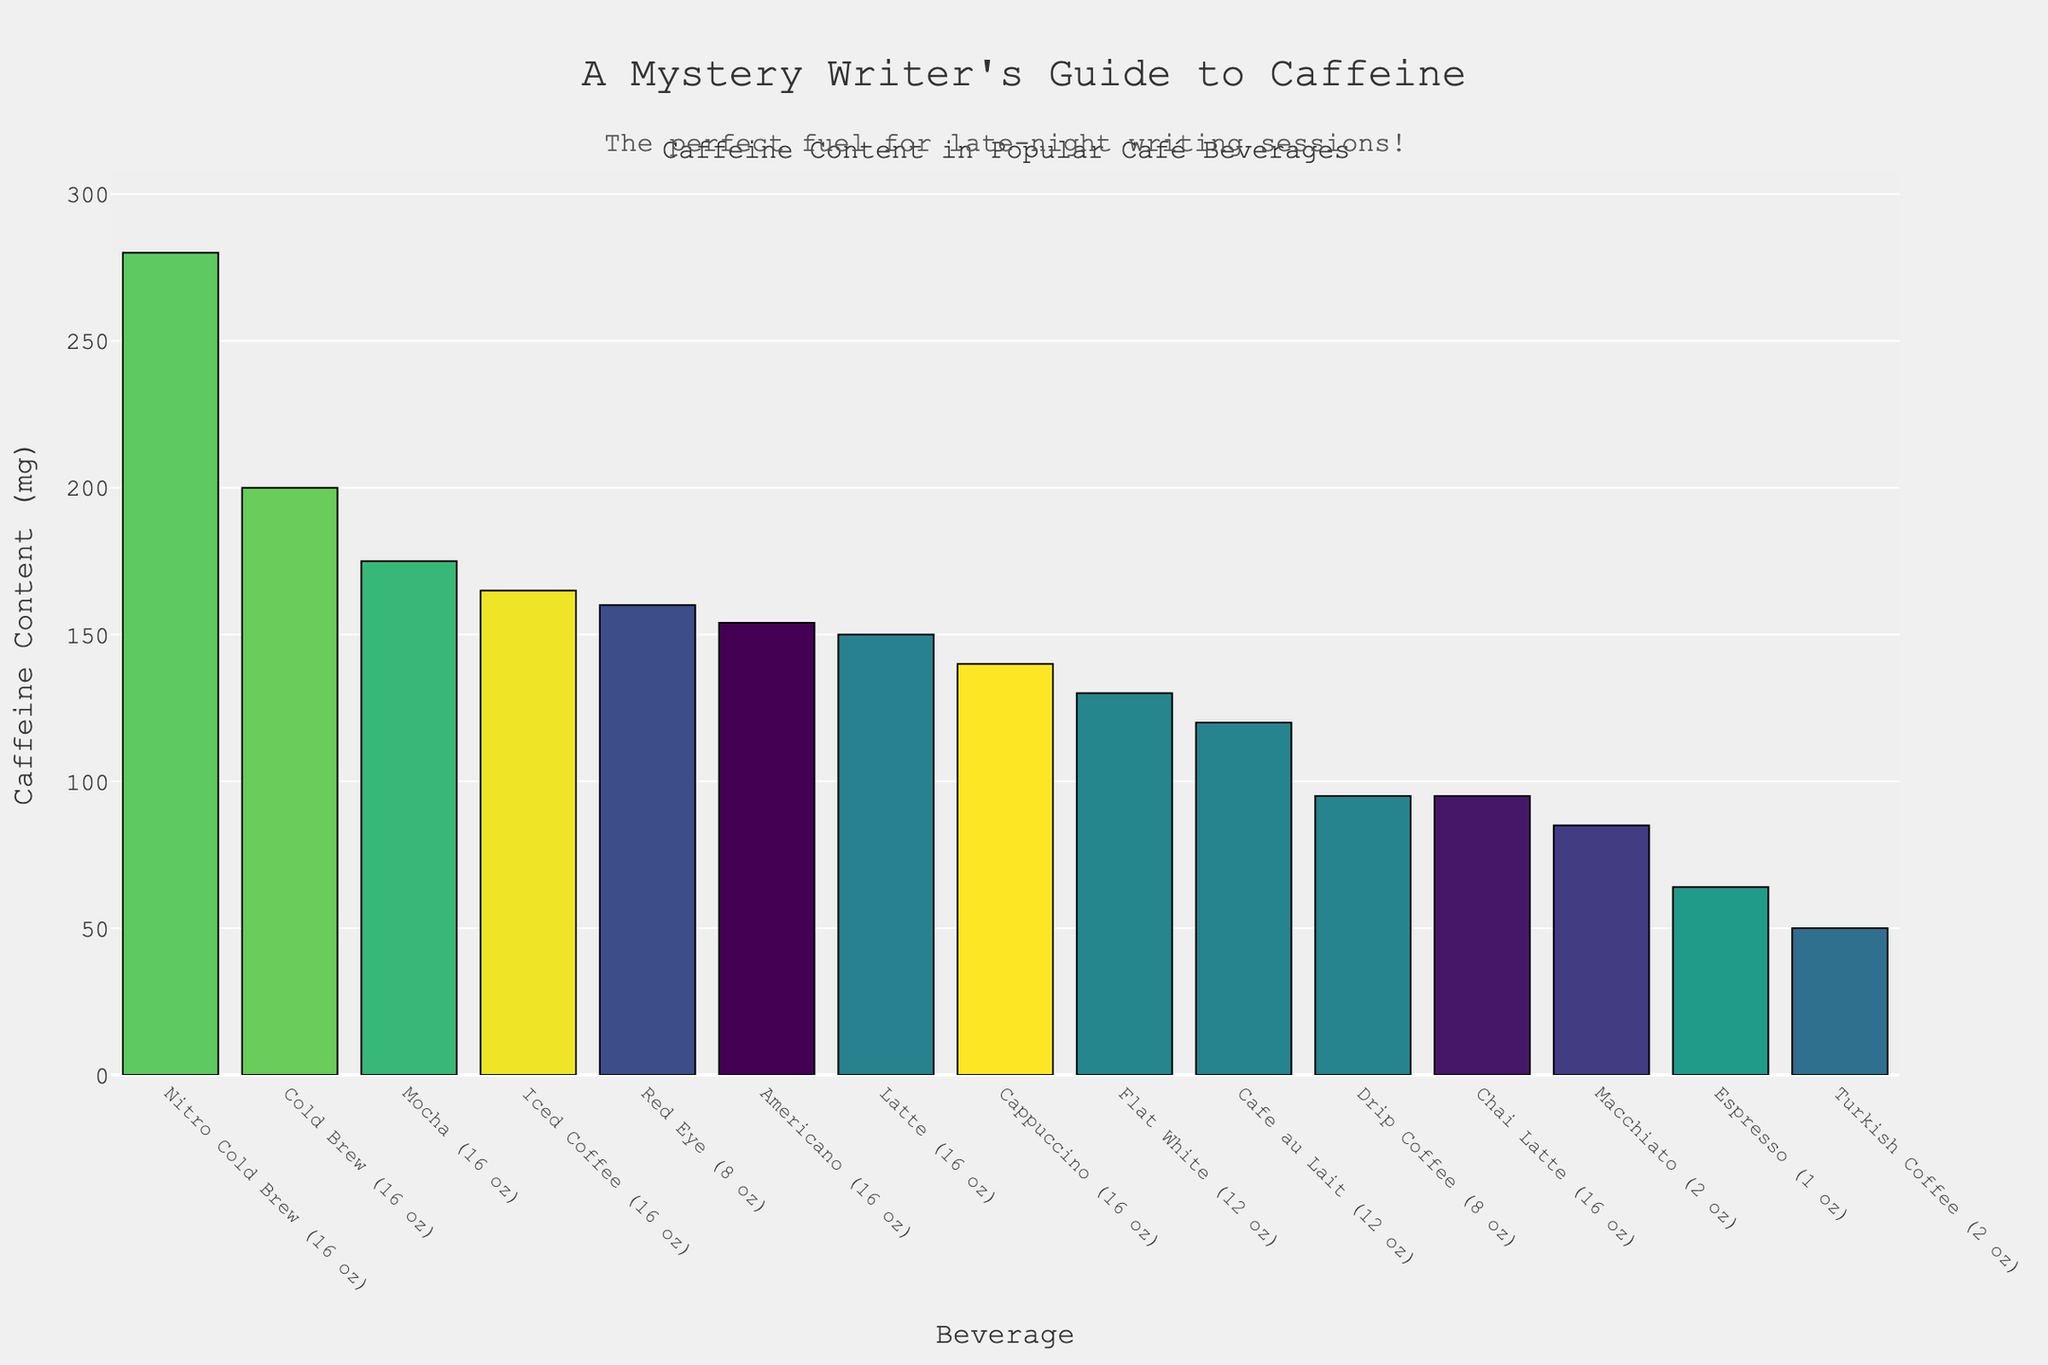What's the beverage with the highest caffeine content? To determine this, look for the tallest bar in the chart. The highest bar represents Nitro Cold Brew with 280 mg of caffeine.
Answer: Nitro Cold Brew Which beverage contains less caffeine: Latte or Cappuccino? Compare the heights of the bars marked for Latte and Cappuccino. The Latte's bar is slightly taller than the Cappuccino's, indicating that Latte has 150 mg of caffeine, while Cappuccino has 140 mg.
Answer: Cappuccino How much more caffeine does Nitro Cold Brew have compared to Espresso? Identify the caffeine amounts for Nitro Cold Brew (280 mg) and Espresso (64 mg) and subtract the smaller value from the larger one: 280 - 64.
Answer: 216 mg What is the total caffeine content if you combine a Macchiato and a Cappuccino? Add the caffeine contents of Macchiato (85 mg) and Cappuccino (140 mg): 85 + 140.
Answer: 225 mg Which beverages have less than 100 mg of caffeine? Identify the bars with values under 100 mg. Espresso (64 mg), Chai Latte (95 mg), and Turkish Coffee (50 mg) fall under this category.
Answer: Espresso, Chai Latte, Turkish Coffee Is the caffeine content in Mocha more than twice that of Turkish Coffee? Compare the caffeine contents of Mocha (175 mg) and Turkish Coffee (50 mg). Double the Turkish Coffee's value is 50 * 2 = 100 mg, which is less than the caffeine content in Mocha.
Answer: Yes What is the difference in caffeine content between the Iced Coffee and Red Eye? Identify the caffeine amounts for Iced Coffee (165 mg) and Red Eye (160 mg) and subtract the smaller value from the larger one: 165 - 160.
Answer: 5 mg Which beverage has a caffeine content closest to 150 mg? Look at the bars around 150 mg. Latte (150 mg) and Cappuccino (140 mg) are close, but Latte is exactly 150 mg.
Answer: Latte What is the median caffeine content among all beverages? List the caffeine contents in ascending order and find the middle value. The sorted list: 50, 64, 85, 95, 95, 120, 130, 140, 150, 154, 160, 165, 175, 200, 280. The middle value is 140 mg.
Answer: 140 mg How many beverages have more caffeine than a Latte? Count the bars taller than the Latte's bar (150 mg). There are six beverages: Americano (154 mg), Red Eye (160 mg), Iced Coffee (165 mg), Mocha (175 mg), Cold Brew (200 mg), Nitro Cold Brew (280 mg).
Answer: Six 